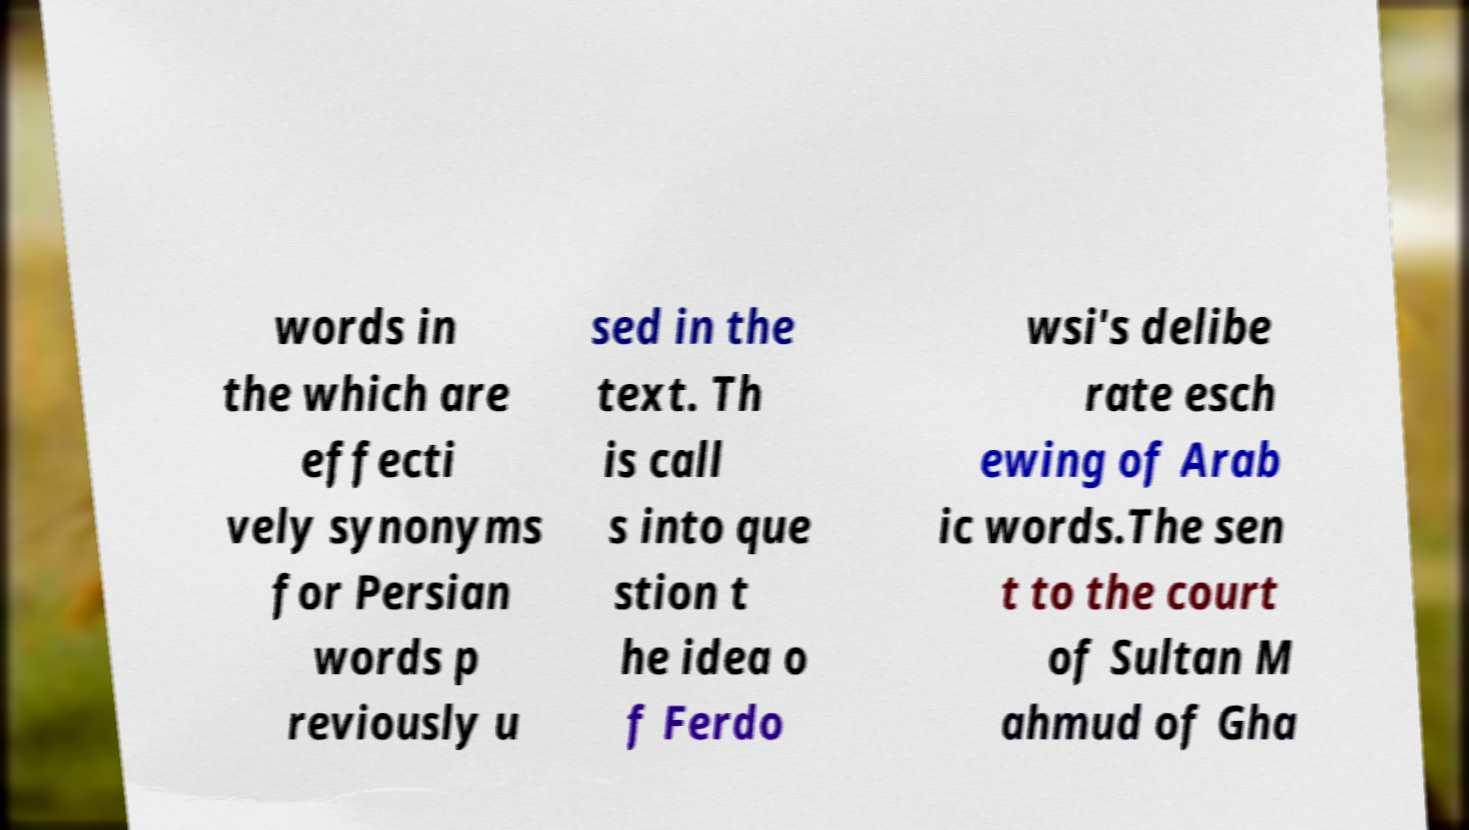Please read and relay the text visible in this image. What does it say? words in the which are effecti vely synonyms for Persian words p reviously u sed in the text. Th is call s into que stion t he idea o f Ferdo wsi's delibe rate esch ewing of Arab ic words.The sen t to the court of Sultan M ahmud of Gha 